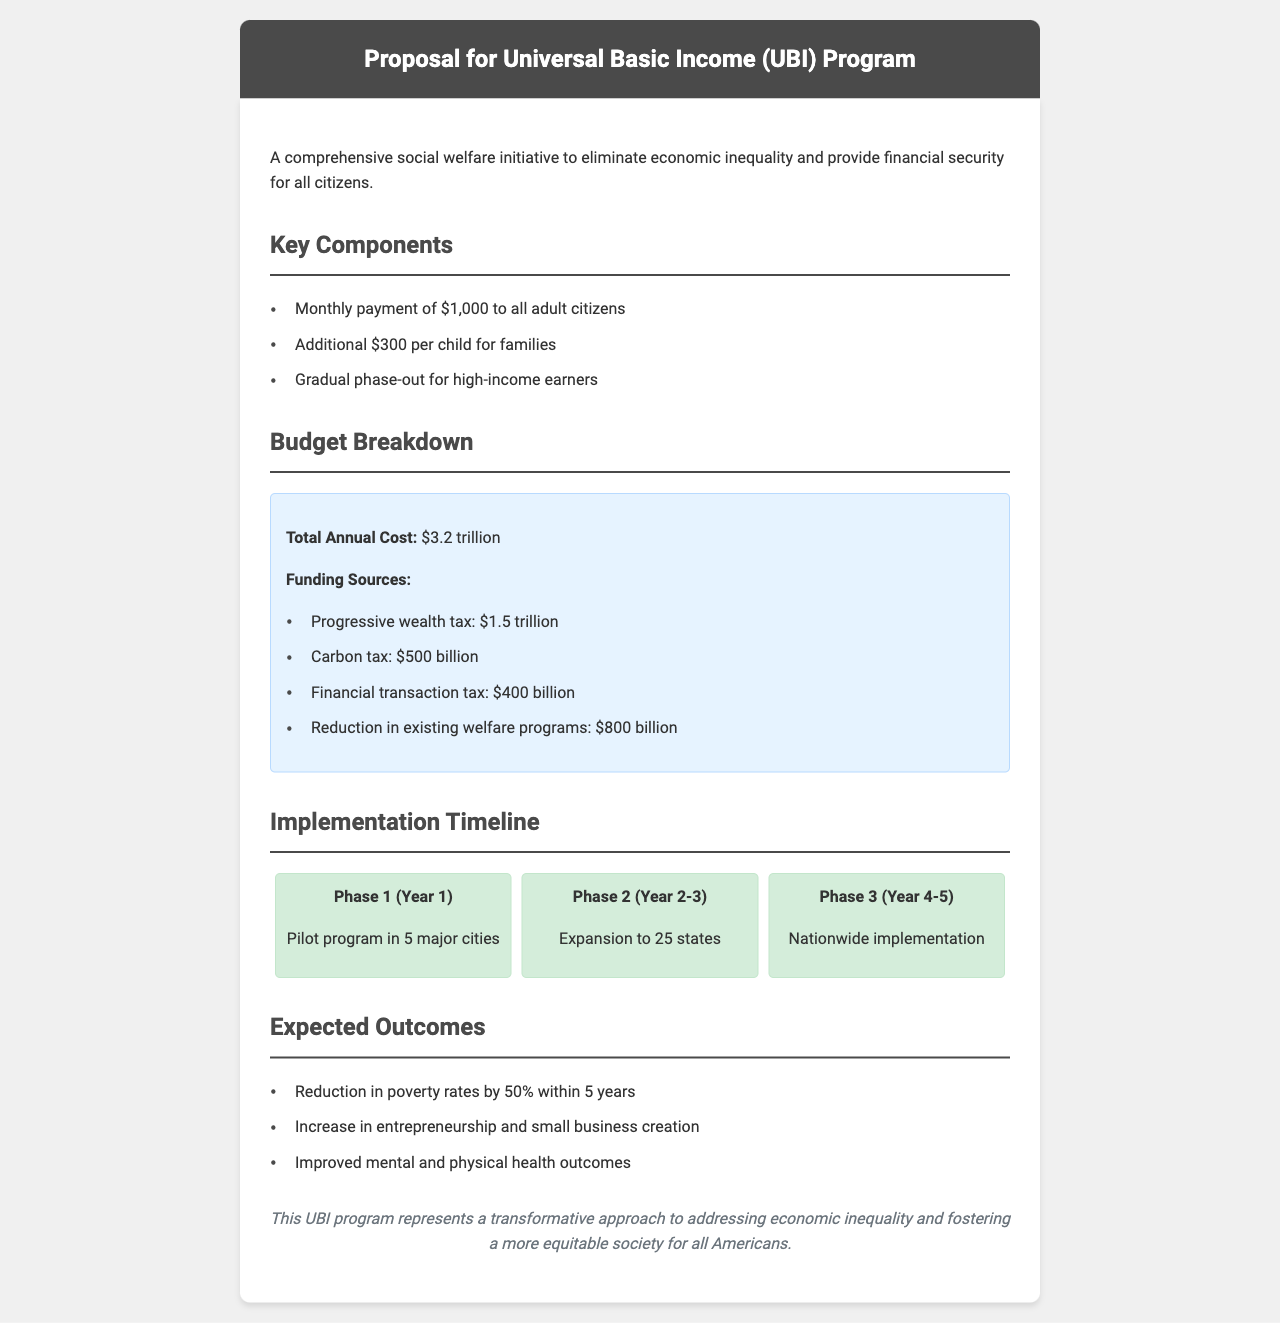what is the monthly payment for adult citizens? The document states that the monthly payment for adult citizens is $1,000.
Answer: $1,000 what is the total annual cost of the UBI program? The total annual cost of the UBI program is listed as $3.2 trillion.
Answer: $3.2 trillion how many phases are there in the implementation timeline? The document outlines three phases in the implementation timeline.
Answer: three what is the funding source that contributes $500 billion? The funding source contributing $500 billion is the carbon tax.
Answer: carbon tax what is the expected reduction in poverty rates within 5 years? The expected reduction in poverty rates is specified as 50% within 5 years.
Answer: 50% what is the primary goal of the UBI program? The primary goal of the UBI program is to eliminate economic inequality and provide financial security.
Answer: eliminate economic inequality what is the conclusion of the document? The conclusion states that the UBI program represents a transformative approach to addressing economic inequality.
Answer: transformative approach during which year is the pilot program scheduled to start? The pilot program is scheduled to start in the first year, which is Year 1.
Answer: Year 1 